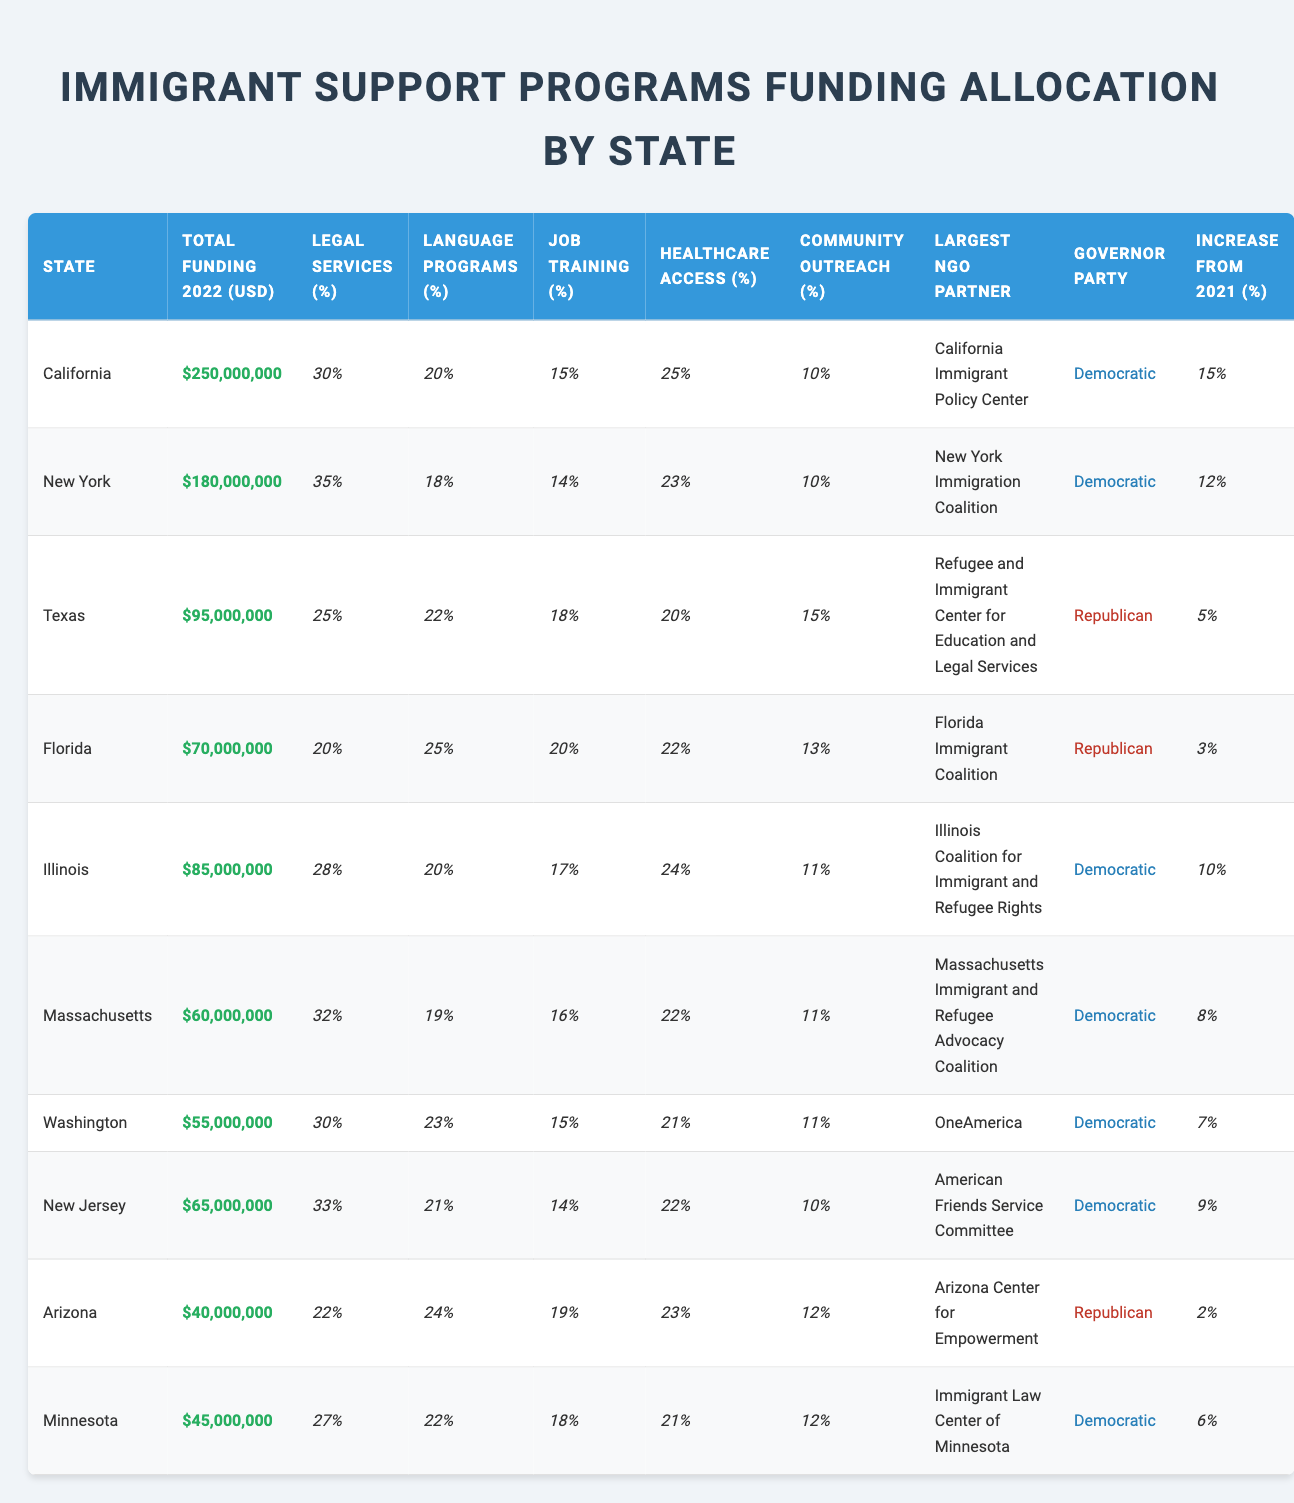What state received the highest total funding for immigrant support programs in 2022? California received the highest total funding at $250,000,000. This can be directly found by comparing the "Total Funding 2022 (USD)" column across all states.
Answer: California Which state has the lowest percentage allocation for legal services? Texas has the lowest percentage allocation for legal services at 25%. We can identify this by looking for the minimum value in the "Legal Services (%)" column.
Answer: Texas What is the average funding allocated to job training programs across all states? The total funding allocated to job training can be found by summing the percentages: (15 + 14 + 18 + 20 + 17 + 16 + 15 + 14 + 19 + 18) =  180, then dividing by 10 (the number of states) to find the average: 180/10 = 18%.
Answer: 18% Which state allocated the highest percentage to language programs? Arizona allocated the highest percentage to language programs at 24%. This is determined by checking the "Language Programs (%)" column for the highest value.
Answer: Arizona Is it true that the states with Democratic governors generally allocated more funding than those with Republican governors? Yes, the data shows that states with Democratic governors (California, New York, Illinois, Massachusetts, Washington, New Jersey, Minnesota) have higher total funding than those with Republican governors (Texas, Florida, and Arizona). By sorting and comparing the total funding amounts, we can verify this.
Answer: Yes What is the percentage increase in funding for immigrant support programs in Florida from 2021 to 2022? The percentage increase in Florida is 3%. This is taken directly from the "Increase from 2021 (%)" column for Florida.
Answer: 3% What is the total funding allocated to healthcare access programs across all states? To find the total funding allocated to healthcare access, add the respective allocations: (25 + 23 + 20 + 22 + 24 + 22 + 21 + 22 + 23 + 21) =  23.2%. To get the total spent, we need to compute each state’s healthcare budget, which requires knowing the total funding first, then applying the percentages.
Answer: 23.2% How many states allocated over 20% of their funding to community outreach? Three states (Florida, Texas, and Arizona) allocated over 20% of their funding to community outreach programs. This can be seen by listing the values from the "Community Outreach (%)" column that are above 20.
Answer: Three Which state has the largest NGO partner for immigrant support programs? California has the largest NGO partner, which is the California Immigrant Policy Center. This is found in the "Largest NGO Partner" column correlated with California's entry.
Answer: California Immigrant Policy Center Calculate the average percentage allocation to healthcare access across all states. The total percentage for healthcare access programs is (25 + 23 + 20 + 22 + 24 + 22 + 21 + 22 + 23 + 21) =  22.2%, calculated by dividing the total by the number of states: 222/10 = 22.2%.
Answer: 22.2% 